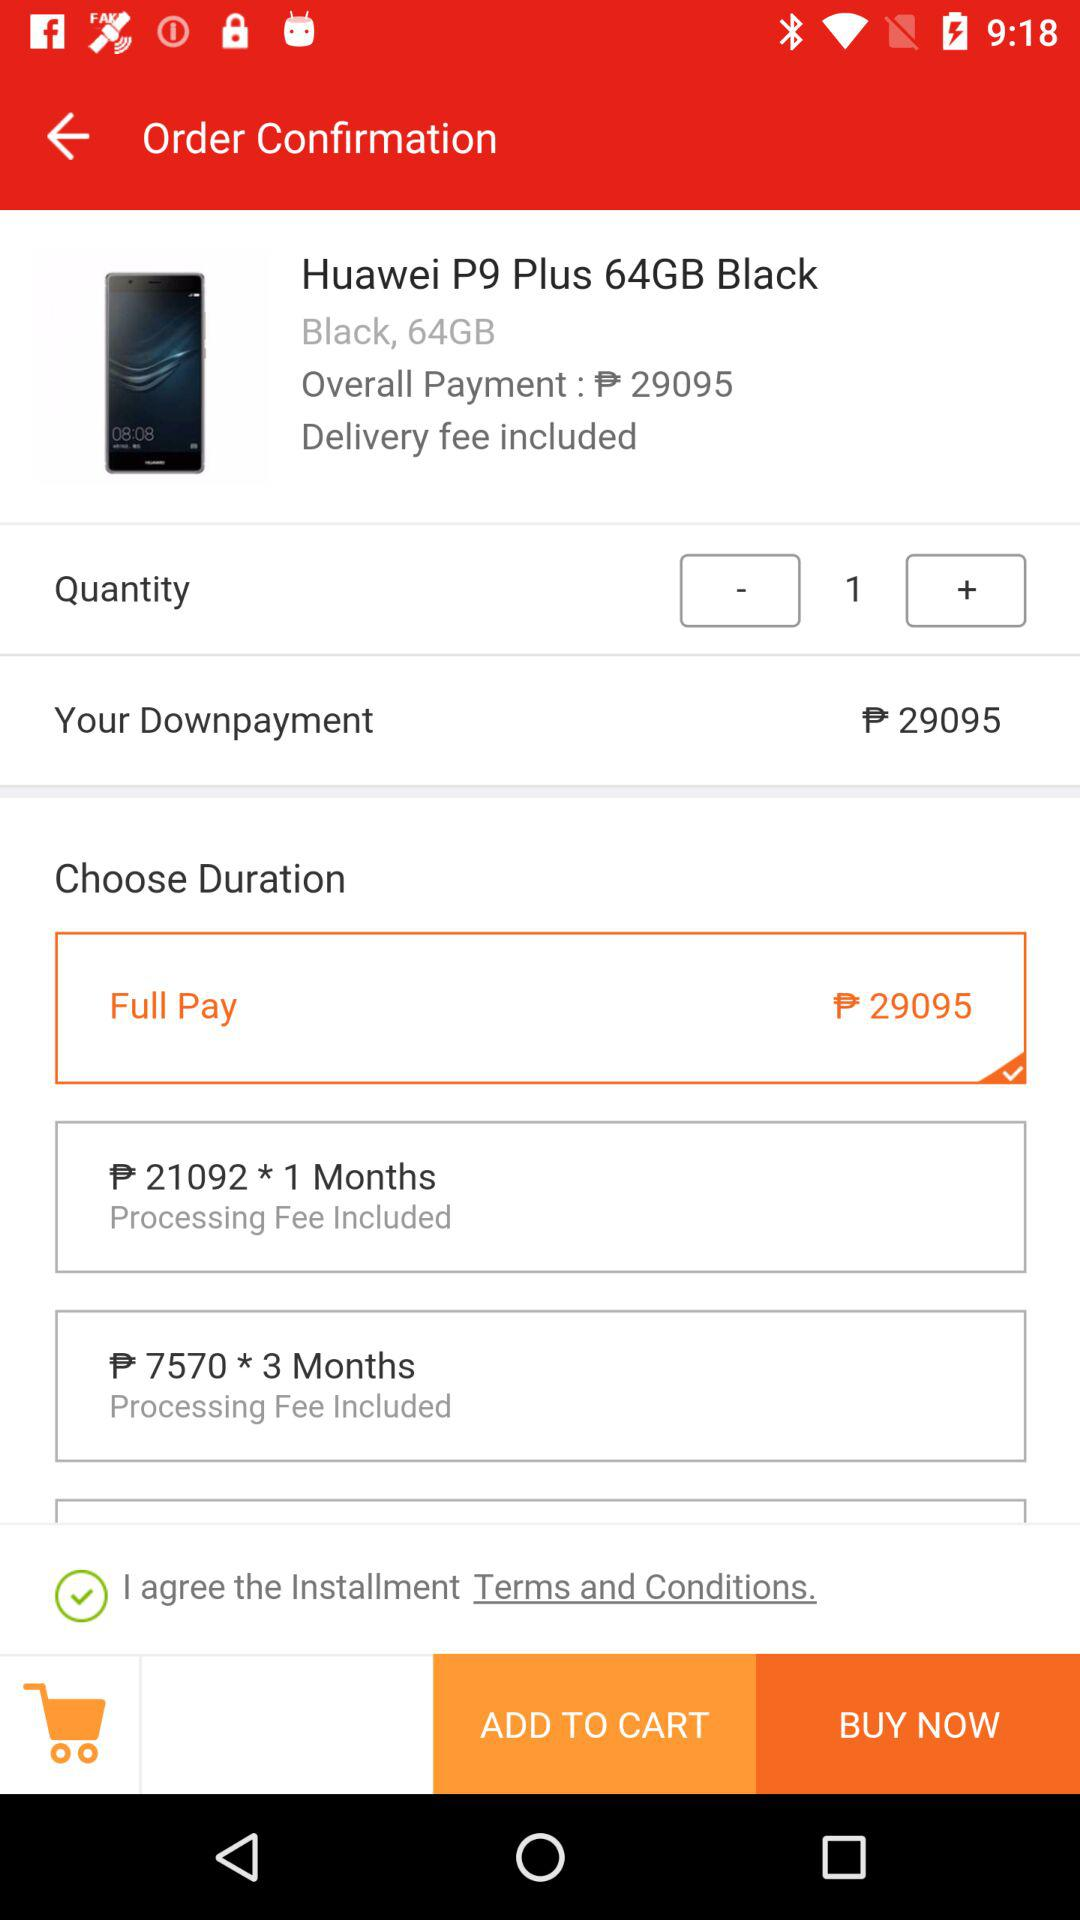How much is the downpayment if I choose to pay in full?
Answer the question using a single word or phrase. 29095 